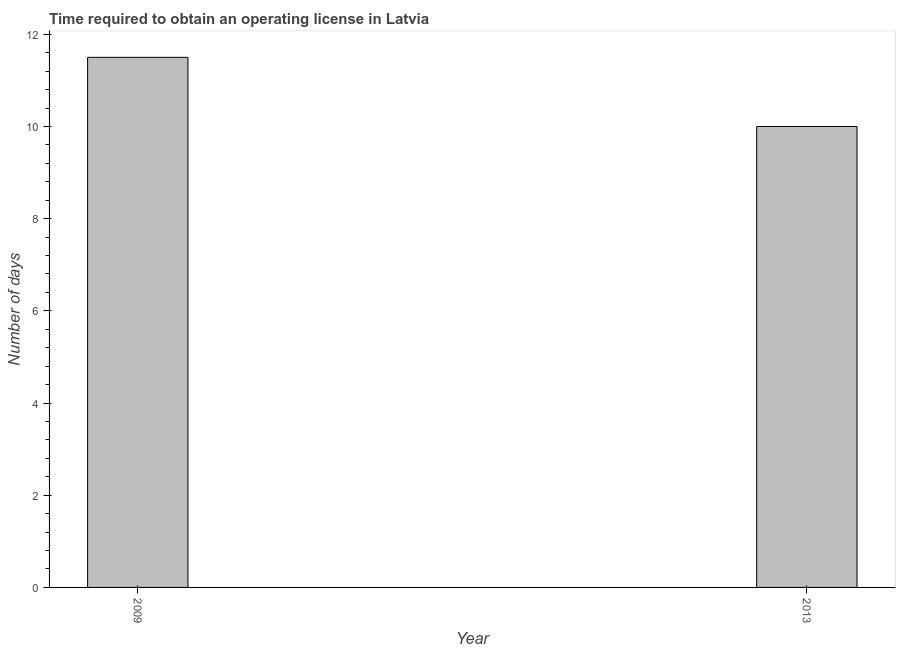Does the graph contain any zero values?
Provide a short and direct response. No. Does the graph contain grids?
Your answer should be compact. No. What is the title of the graph?
Offer a very short reply. Time required to obtain an operating license in Latvia. What is the label or title of the Y-axis?
Your answer should be very brief. Number of days. What is the number of days to obtain operating license in 2009?
Provide a succinct answer. 11.5. Across all years, what is the maximum number of days to obtain operating license?
Your response must be concise. 11.5. In which year was the number of days to obtain operating license maximum?
Offer a very short reply. 2009. What is the difference between the number of days to obtain operating license in 2009 and 2013?
Provide a short and direct response. 1.5. What is the average number of days to obtain operating license per year?
Provide a succinct answer. 10.75. What is the median number of days to obtain operating license?
Your response must be concise. 10.75. Do a majority of the years between 2009 and 2013 (inclusive) have number of days to obtain operating license greater than 8.4 days?
Make the answer very short. Yes. What is the ratio of the number of days to obtain operating license in 2009 to that in 2013?
Keep it short and to the point. 1.15. In how many years, is the number of days to obtain operating license greater than the average number of days to obtain operating license taken over all years?
Provide a short and direct response. 1. How many bars are there?
Offer a very short reply. 2. What is the Number of days in 2009?
Offer a very short reply. 11.5. What is the ratio of the Number of days in 2009 to that in 2013?
Keep it short and to the point. 1.15. 